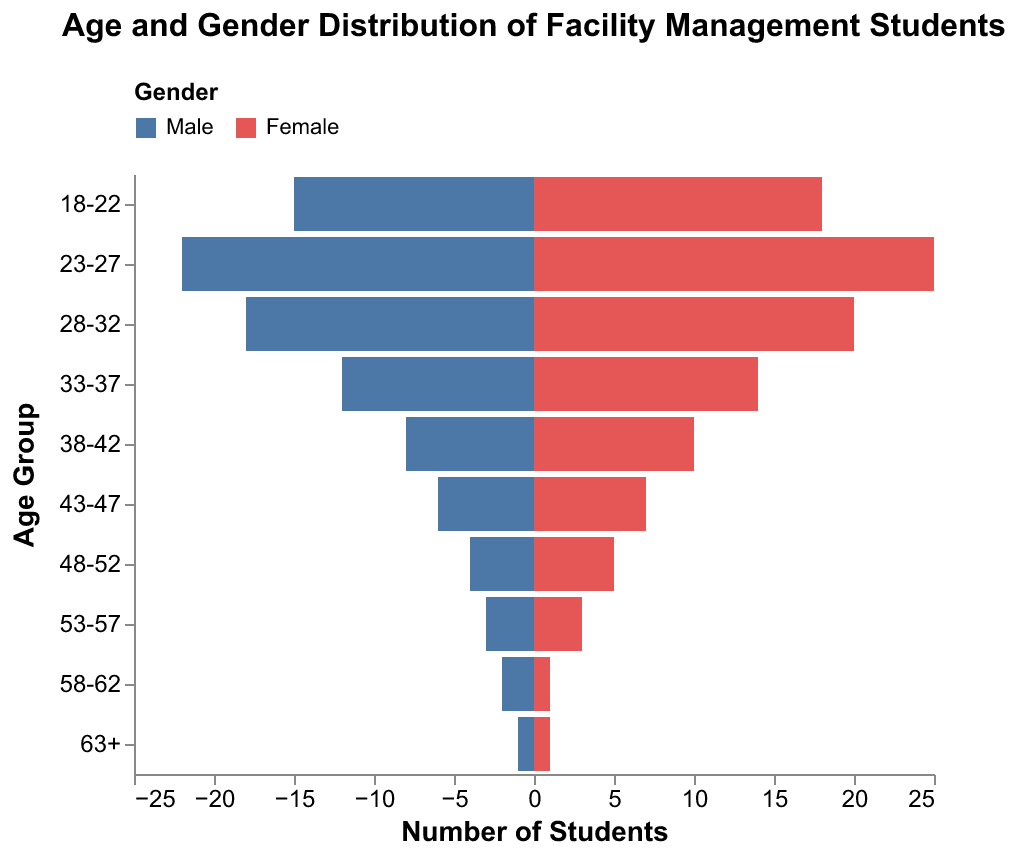What is the title of the figure? The title of the figure is displayed prominently at the top, summarizing the content. It reads "Age and Gender Distribution of Facility Management Students."
Answer: Age and Gender Distribution of Facility Management Students What is the age group with the highest number of students enrolled? By comparing the lengths of the bars in the pyramid visually, the age group 23-27 shows the highest combined value (Male: 22, Female: 25).
Answer: 23-27 Which gender has more students in the age group 33-37? By observing the bars of both genders in the 33-37 age group, the Female bar is slightly longer than the Male bar (Female: 14, Male: 12).
Answer: Female What is the combined number of students in the 58-62 age group? To find the combined total, you sum the number of Male and Female students in the 58-62 age group (Male: 2, Female: 1). 2 + 1 = 3
Answer: 3 How many female students are enrolled in the age group 23-27? Looking at the length of the Female bar for the 23-27 age group, it shows the value 25.
Answer: 25 Which age group has the smallest number of male students? By visually comparing the lengths of the Male bars across all age groups, the age group 63+ shows the smallest number (1 Male).
Answer: 63+ In the age group 28-32, how many more female students are there compared to male students? By comparing the lengths of the bars, the Female bar for 28-32 is 20, and the Male bar is 18. So, 20 - 18 = 2 more Female students.
Answer: 2 Are there more students aged 18-22 or aged 38-42? To compare, combine the total number of students for both age groups. For 18-22, the total is 15 + 18 = 33. For 38-42, the total is 8 + 10 = 18. 33 is greater than 18, so there are more students aged 18-22.
Answer: 18-22 What is the average number of students in the age groups 48-52 and 53-57? First, find the total number of students in each age group and then calculate the average. For 48-52, the total is 4 + 5 = 9. For 53-57, the total is 3 + 3 = 6. The combined total is 9 + 6 = 15. There are 2 age groups, so the average is 15 / 2 = 7.5
Answer: 7.5 What is the median number of students in the Male age groups? List the number of male students in all age groups: 15, 22, 18, 12, 8, 6, 4, 3, 2, 1. To find the median, order the values: 1, 2, 3, 4, 6, 8, 12, 15, 18, 22. The middle value for these 10 numbers is the average of the 5th and 6th values. (6 + 8) / 2 = 7
Answer: 7 